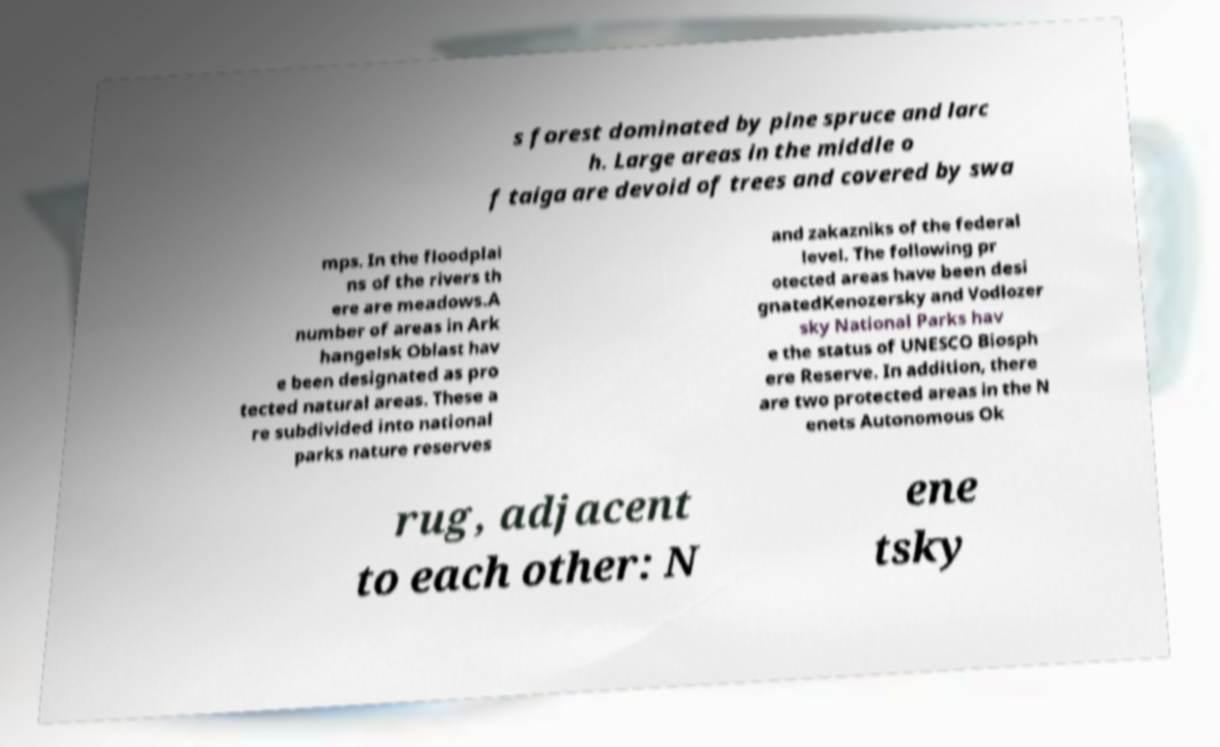Could you extract and type out the text from this image? s forest dominated by pine spruce and larc h. Large areas in the middle o f taiga are devoid of trees and covered by swa mps. In the floodplai ns of the rivers th ere are meadows.A number of areas in Ark hangelsk Oblast hav e been designated as pro tected natural areas. These a re subdivided into national parks nature reserves and zakazniks of the federal level. The following pr otected areas have been desi gnatedKenozersky and Vodlozer sky National Parks hav e the status of UNESCO Biosph ere Reserve. In addition, there are two protected areas in the N enets Autonomous Ok rug, adjacent to each other: N ene tsky 